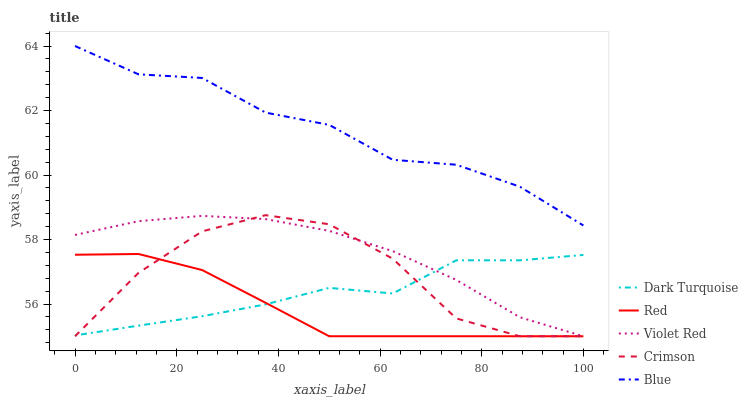Does Red have the minimum area under the curve?
Answer yes or no. Yes. Does Blue have the maximum area under the curve?
Answer yes or no. Yes. Does Dark Turquoise have the minimum area under the curve?
Answer yes or no. No. Does Dark Turquoise have the maximum area under the curve?
Answer yes or no. No. Is Red the smoothest?
Answer yes or no. Yes. Is Crimson the roughest?
Answer yes or no. Yes. Is Dark Turquoise the smoothest?
Answer yes or no. No. Is Dark Turquoise the roughest?
Answer yes or no. No. Does Crimson have the lowest value?
Answer yes or no. Yes. Does Dark Turquoise have the lowest value?
Answer yes or no. No. Does Blue have the highest value?
Answer yes or no. Yes. Does Violet Red have the highest value?
Answer yes or no. No. Is Crimson less than Blue?
Answer yes or no. Yes. Is Blue greater than Dark Turquoise?
Answer yes or no. Yes. Does Dark Turquoise intersect Crimson?
Answer yes or no. Yes. Is Dark Turquoise less than Crimson?
Answer yes or no. No. Is Dark Turquoise greater than Crimson?
Answer yes or no. No. Does Crimson intersect Blue?
Answer yes or no. No. 